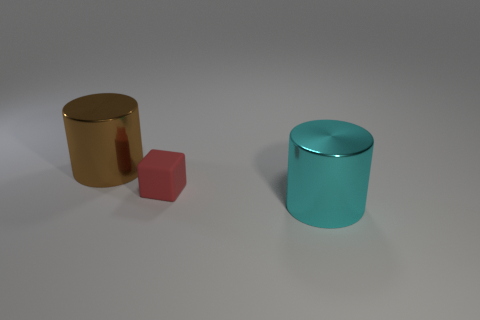Add 3 large shiny objects. How many objects exist? 6 Subtract all blocks. How many objects are left? 2 Add 1 big gray metallic things. How many big gray metallic things exist? 1 Subtract all brown cylinders. How many cylinders are left? 1 Subtract 1 red blocks. How many objects are left? 2 Subtract all gray blocks. Subtract all yellow cylinders. How many blocks are left? 1 Subtract all yellow spheres. How many blue cylinders are left? 0 Subtract all big purple shiny cubes. Subtract all big cylinders. How many objects are left? 1 Add 2 small rubber things. How many small rubber things are left? 3 